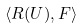<formula> <loc_0><loc_0><loc_500><loc_500>\langle R ( U ) , F \rangle</formula> 